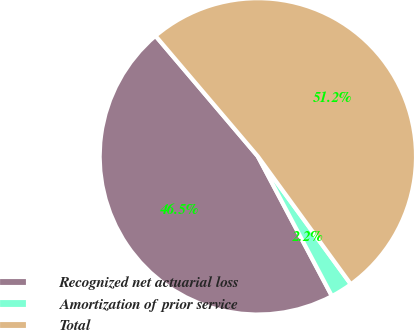Convert chart to OTSL. <chart><loc_0><loc_0><loc_500><loc_500><pie_chart><fcel>Recognized net actuarial loss<fcel>Amortization of prior service<fcel>Total<nl><fcel>46.55%<fcel>2.25%<fcel>51.2%<nl></chart> 